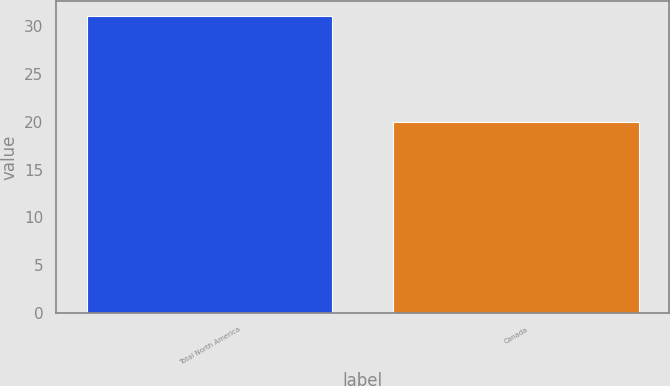Convert chart to OTSL. <chart><loc_0><loc_0><loc_500><loc_500><bar_chart><fcel>Total North America<fcel>Canada<nl><fcel>31<fcel>20<nl></chart> 